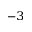Convert formula to latex. <formula><loc_0><loc_0><loc_500><loc_500>^ { - 3 }</formula> 